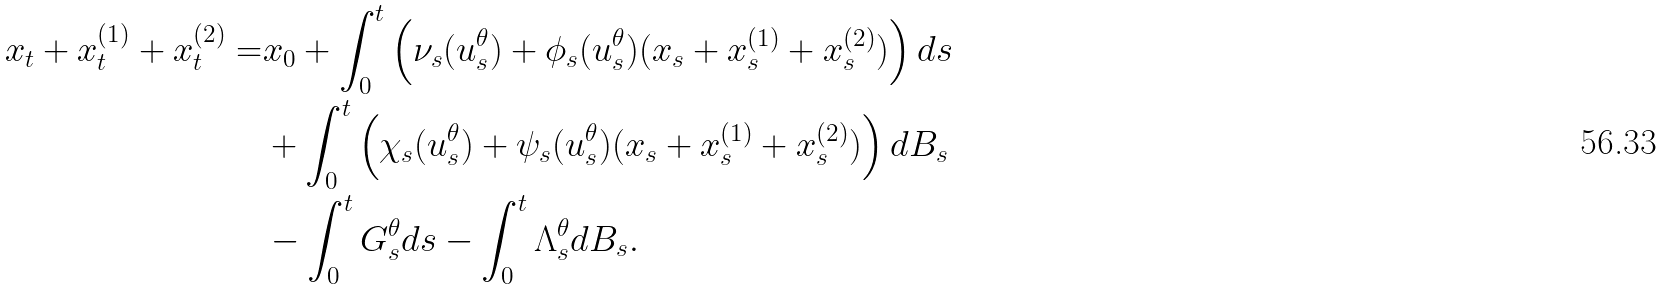<formula> <loc_0><loc_0><loc_500><loc_500>x _ { t } + x _ { t } ^ { ( 1 ) } + x _ { t } ^ { ( 2 ) } = & x _ { 0 } + \int _ { 0 } ^ { t } \left ( \nu _ { s } ( u ^ { \theta } _ { s } ) + \phi _ { s } ( u ^ { \theta } _ { s } ) ( x _ { s } + x _ { s } ^ { ( 1 ) } + x _ { s } ^ { ( 2 ) } ) \right ) d s \\ & + \int _ { 0 } ^ { t } \left ( \chi _ { s } ( u ^ { \theta } _ { s } ) + \psi _ { s } ( u ^ { \theta } _ { s } ) ( x _ { s } + x _ { s } ^ { ( 1 ) } + x _ { s } ^ { ( 2 ) } ) \right ) d B _ { s } \\ & - \int _ { 0 } ^ { t } G ^ { \theta } _ { s } d s - \int _ { 0 } ^ { t } \Lambda ^ { \theta } _ { s } d B _ { s } .</formula> 